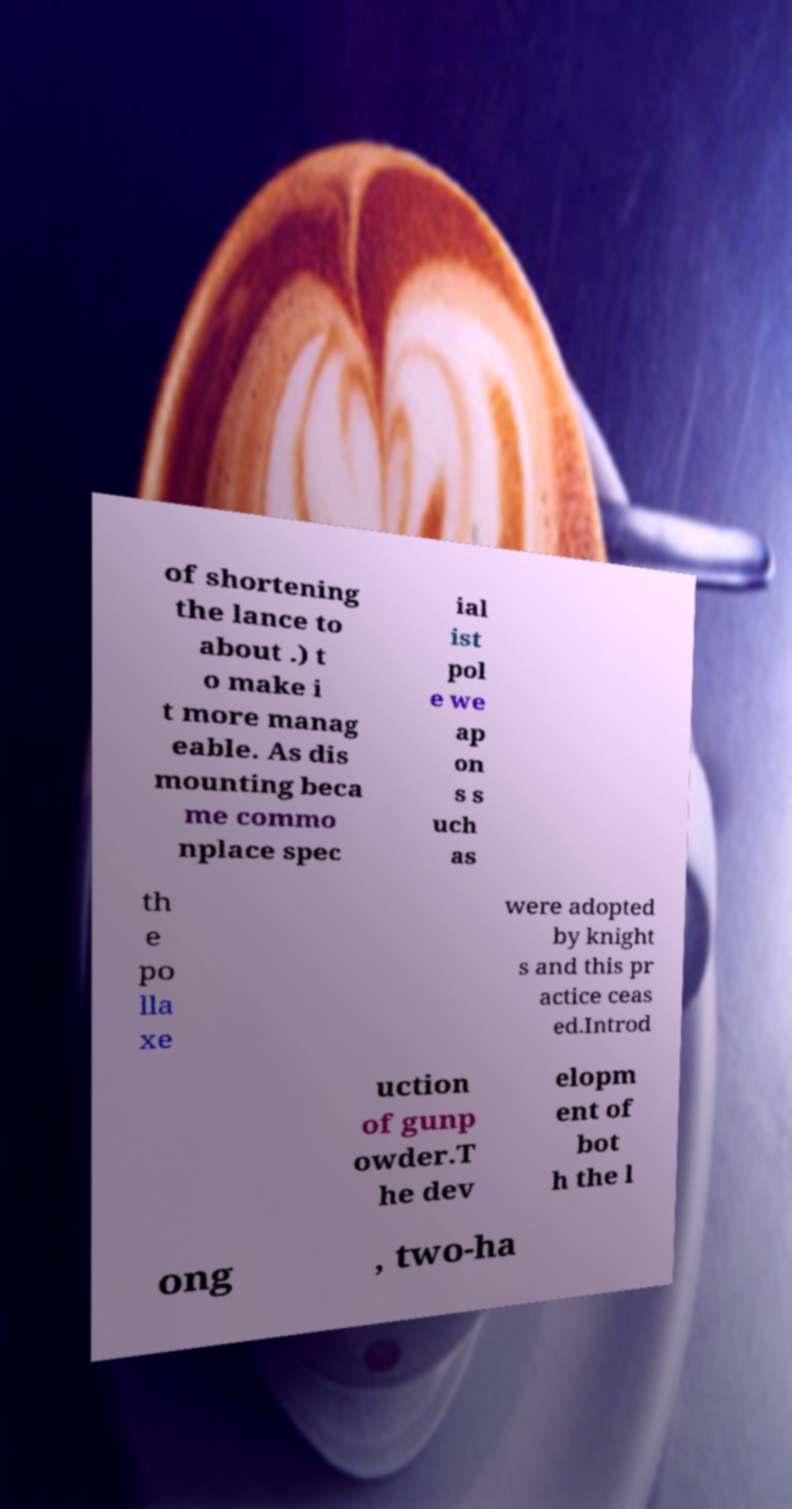There's text embedded in this image that I need extracted. Can you transcribe it verbatim? of shortening the lance to about .) t o make i t more manag eable. As dis mounting beca me commo nplace spec ial ist pol e we ap on s s uch as th e po lla xe were adopted by knight s and this pr actice ceas ed.Introd uction of gunp owder.T he dev elopm ent of bot h the l ong , two-ha 